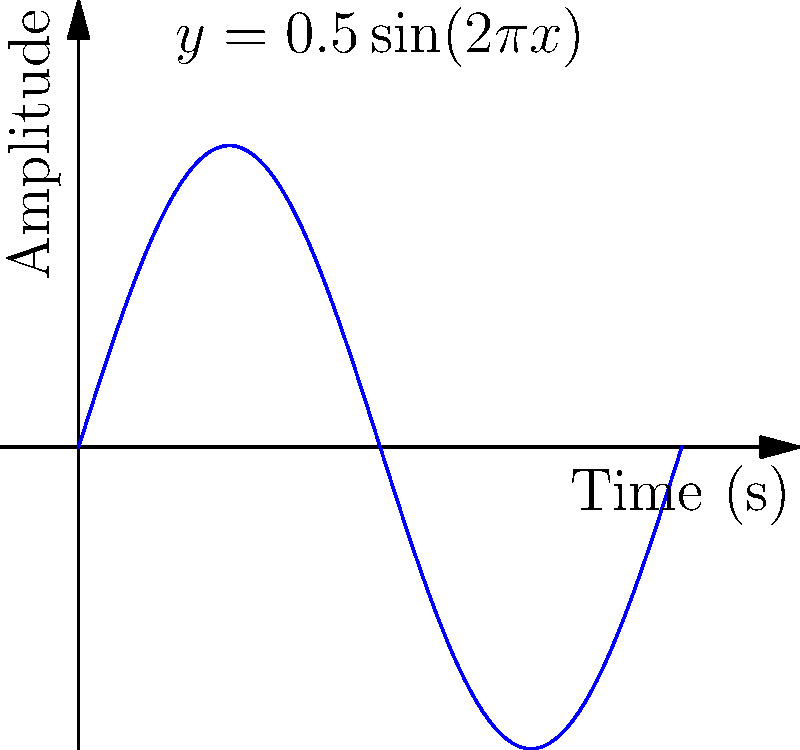A musical note can be represented by the waveform $y = 0.5\sin(2\pi x)$, where $x$ is time in seconds and $y$ is amplitude. The energy of the note is proportional to the area under the squared waveform curve over one period. Calculate the energy of this note over one period (from 0 to 1 second) using calculus. Let's approach this step-by-step:

1) The energy is proportional to the area under the squared waveform curve. So we need to integrate $[0.5\sin(2\pi x)]^2$ from 0 to 1.

2) Let's set up the integral:
   $$E = \int_0^1 [0.5\sin(2\pi x)]^2 dx$$

3) Simplify the integrand:
   $$E = \int_0^1 0.25\sin^2(2\pi x) dx$$

4) We can use the trigonometric identity: $\sin^2 \theta = \frac{1 - \cos(2\theta)}{2}$
   $$E = \int_0^1 0.25 \cdot \frac{1 - \cos(4\pi x)}{2} dx$$

5) Simplify:
   $$E = \int_0^1 \frac{1}{8} - \frac{1}{8}\cos(4\pi x) dx$$

6) Integrate:
   $$E = [\frac{1}{8}x - \frac{1}{32\pi}\sin(4\pi x)]_0^1$$

7) Evaluate the integral:
   $$E = (\frac{1}{8} - 0) - (0 - 0) = \frac{1}{8}$$

Therefore, the energy of the note over one period is $\frac{1}{8}$ (in arbitrary energy units).
Answer: $\frac{1}{8}$ 